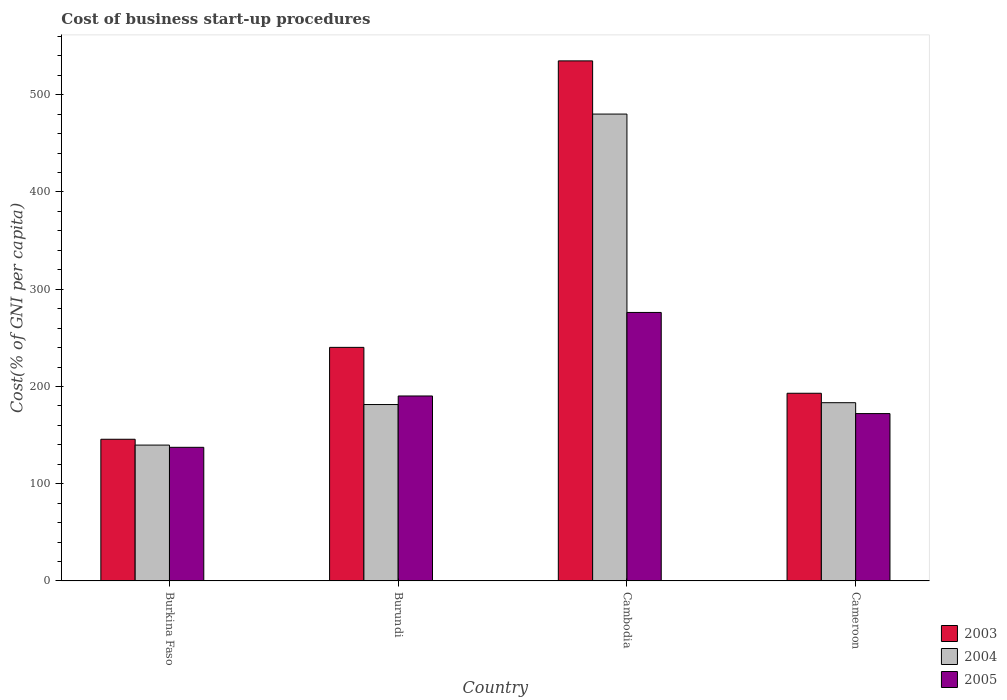How many different coloured bars are there?
Your response must be concise. 3. Are the number of bars per tick equal to the number of legend labels?
Give a very brief answer. Yes. How many bars are there on the 4th tick from the left?
Offer a terse response. 3. What is the label of the 4th group of bars from the left?
Give a very brief answer. Cameroon. What is the cost of business start-up procedures in 2003 in Cambodia?
Keep it short and to the point. 534.8. Across all countries, what is the maximum cost of business start-up procedures in 2003?
Ensure brevity in your answer.  534.8. Across all countries, what is the minimum cost of business start-up procedures in 2005?
Offer a very short reply. 137.4. In which country was the cost of business start-up procedures in 2005 maximum?
Ensure brevity in your answer.  Cambodia. In which country was the cost of business start-up procedures in 2005 minimum?
Make the answer very short. Burkina Faso. What is the total cost of business start-up procedures in 2004 in the graph?
Ensure brevity in your answer.  984.5. What is the difference between the cost of business start-up procedures in 2003 in Burundi and that in Cameroon?
Make the answer very short. 47.2. What is the difference between the cost of business start-up procedures in 2005 in Burundi and the cost of business start-up procedures in 2003 in Cambodia?
Offer a terse response. -344.6. What is the average cost of business start-up procedures in 2004 per country?
Make the answer very short. 246.12. What is the difference between the cost of business start-up procedures of/in 2005 and cost of business start-up procedures of/in 2004 in Burkina Faso?
Your response must be concise. -2.3. In how many countries, is the cost of business start-up procedures in 2003 greater than 500 %?
Offer a terse response. 1. What is the ratio of the cost of business start-up procedures in 2005 in Burkina Faso to that in Cambodia?
Offer a very short reply. 0.5. What is the difference between the highest and the second highest cost of business start-up procedures in 2003?
Offer a terse response. 47.2. What is the difference between the highest and the lowest cost of business start-up procedures in 2004?
Your answer should be very brief. 340.4. What does the 2nd bar from the left in Burundi represents?
Offer a very short reply. 2004. Is it the case that in every country, the sum of the cost of business start-up procedures in 2004 and cost of business start-up procedures in 2005 is greater than the cost of business start-up procedures in 2003?
Provide a succinct answer. Yes. How many bars are there?
Your answer should be compact. 12. Are all the bars in the graph horizontal?
Offer a terse response. No. How many countries are there in the graph?
Make the answer very short. 4. Are the values on the major ticks of Y-axis written in scientific E-notation?
Your answer should be very brief. No. How are the legend labels stacked?
Your response must be concise. Vertical. What is the title of the graph?
Keep it short and to the point. Cost of business start-up procedures. What is the label or title of the X-axis?
Offer a terse response. Country. What is the label or title of the Y-axis?
Make the answer very short. Cost(% of GNI per capita). What is the Cost(% of GNI per capita) of 2003 in Burkina Faso?
Give a very brief answer. 145.7. What is the Cost(% of GNI per capita) in 2004 in Burkina Faso?
Make the answer very short. 139.7. What is the Cost(% of GNI per capita) in 2005 in Burkina Faso?
Provide a succinct answer. 137.4. What is the Cost(% of GNI per capita) in 2003 in Burundi?
Your answer should be very brief. 240.2. What is the Cost(% of GNI per capita) of 2004 in Burundi?
Make the answer very short. 181.4. What is the Cost(% of GNI per capita) of 2005 in Burundi?
Provide a short and direct response. 190.2. What is the Cost(% of GNI per capita) of 2003 in Cambodia?
Offer a terse response. 534.8. What is the Cost(% of GNI per capita) in 2004 in Cambodia?
Your answer should be very brief. 480.1. What is the Cost(% of GNI per capita) in 2005 in Cambodia?
Offer a terse response. 276.1. What is the Cost(% of GNI per capita) of 2003 in Cameroon?
Your response must be concise. 193. What is the Cost(% of GNI per capita) of 2004 in Cameroon?
Ensure brevity in your answer.  183.3. What is the Cost(% of GNI per capita) in 2005 in Cameroon?
Give a very brief answer. 172.1. Across all countries, what is the maximum Cost(% of GNI per capita) of 2003?
Keep it short and to the point. 534.8. Across all countries, what is the maximum Cost(% of GNI per capita) in 2004?
Provide a short and direct response. 480.1. Across all countries, what is the maximum Cost(% of GNI per capita) of 2005?
Offer a very short reply. 276.1. Across all countries, what is the minimum Cost(% of GNI per capita) of 2003?
Provide a short and direct response. 145.7. Across all countries, what is the minimum Cost(% of GNI per capita) in 2004?
Your answer should be compact. 139.7. Across all countries, what is the minimum Cost(% of GNI per capita) of 2005?
Give a very brief answer. 137.4. What is the total Cost(% of GNI per capita) of 2003 in the graph?
Make the answer very short. 1113.7. What is the total Cost(% of GNI per capita) in 2004 in the graph?
Provide a succinct answer. 984.5. What is the total Cost(% of GNI per capita) in 2005 in the graph?
Make the answer very short. 775.8. What is the difference between the Cost(% of GNI per capita) in 2003 in Burkina Faso and that in Burundi?
Offer a very short reply. -94.5. What is the difference between the Cost(% of GNI per capita) of 2004 in Burkina Faso and that in Burundi?
Provide a short and direct response. -41.7. What is the difference between the Cost(% of GNI per capita) of 2005 in Burkina Faso and that in Burundi?
Ensure brevity in your answer.  -52.8. What is the difference between the Cost(% of GNI per capita) in 2003 in Burkina Faso and that in Cambodia?
Offer a very short reply. -389.1. What is the difference between the Cost(% of GNI per capita) in 2004 in Burkina Faso and that in Cambodia?
Your answer should be compact. -340.4. What is the difference between the Cost(% of GNI per capita) of 2005 in Burkina Faso and that in Cambodia?
Ensure brevity in your answer.  -138.7. What is the difference between the Cost(% of GNI per capita) in 2003 in Burkina Faso and that in Cameroon?
Give a very brief answer. -47.3. What is the difference between the Cost(% of GNI per capita) of 2004 in Burkina Faso and that in Cameroon?
Provide a short and direct response. -43.6. What is the difference between the Cost(% of GNI per capita) of 2005 in Burkina Faso and that in Cameroon?
Your response must be concise. -34.7. What is the difference between the Cost(% of GNI per capita) in 2003 in Burundi and that in Cambodia?
Make the answer very short. -294.6. What is the difference between the Cost(% of GNI per capita) of 2004 in Burundi and that in Cambodia?
Offer a terse response. -298.7. What is the difference between the Cost(% of GNI per capita) in 2005 in Burundi and that in Cambodia?
Provide a short and direct response. -85.9. What is the difference between the Cost(% of GNI per capita) of 2003 in Burundi and that in Cameroon?
Give a very brief answer. 47.2. What is the difference between the Cost(% of GNI per capita) of 2004 in Burundi and that in Cameroon?
Offer a very short reply. -1.9. What is the difference between the Cost(% of GNI per capita) of 2005 in Burundi and that in Cameroon?
Provide a succinct answer. 18.1. What is the difference between the Cost(% of GNI per capita) of 2003 in Cambodia and that in Cameroon?
Keep it short and to the point. 341.8. What is the difference between the Cost(% of GNI per capita) in 2004 in Cambodia and that in Cameroon?
Your answer should be compact. 296.8. What is the difference between the Cost(% of GNI per capita) of 2005 in Cambodia and that in Cameroon?
Make the answer very short. 104. What is the difference between the Cost(% of GNI per capita) of 2003 in Burkina Faso and the Cost(% of GNI per capita) of 2004 in Burundi?
Provide a short and direct response. -35.7. What is the difference between the Cost(% of GNI per capita) in 2003 in Burkina Faso and the Cost(% of GNI per capita) in 2005 in Burundi?
Offer a terse response. -44.5. What is the difference between the Cost(% of GNI per capita) of 2004 in Burkina Faso and the Cost(% of GNI per capita) of 2005 in Burundi?
Your answer should be very brief. -50.5. What is the difference between the Cost(% of GNI per capita) in 2003 in Burkina Faso and the Cost(% of GNI per capita) in 2004 in Cambodia?
Your response must be concise. -334.4. What is the difference between the Cost(% of GNI per capita) of 2003 in Burkina Faso and the Cost(% of GNI per capita) of 2005 in Cambodia?
Your answer should be compact. -130.4. What is the difference between the Cost(% of GNI per capita) in 2004 in Burkina Faso and the Cost(% of GNI per capita) in 2005 in Cambodia?
Keep it short and to the point. -136.4. What is the difference between the Cost(% of GNI per capita) of 2003 in Burkina Faso and the Cost(% of GNI per capita) of 2004 in Cameroon?
Offer a very short reply. -37.6. What is the difference between the Cost(% of GNI per capita) in 2003 in Burkina Faso and the Cost(% of GNI per capita) in 2005 in Cameroon?
Provide a short and direct response. -26.4. What is the difference between the Cost(% of GNI per capita) of 2004 in Burkina Faso and the Cost(% of GNI per capita) of 2005 in Cameroon?
Keep it short and to the point. -32.4. What is the difference between the Cost(% of GNI per capita) in 2003 in Burundi and the Cost(% of GNI per capita) in 2004 in Cambodia?
Make the answer very short. -239.9. What is the difference between the Cost(% of GNI per capita) in 2003 in Burundi and the Cost(% of GNI per capita) in 2005 in Cambodia?
Provide a short and direct response. -35.9. What is the difference between the Cost(% of GNI per capita) in 2004 in Burundi and the Cost(% of GNI per capita) in 2005 in Cambodia?
Offer a terse response. -94.7. What is the difference between the Cost(% of GNI per capita) in 2003 in Burundi and the Cost(% of GNI per capita) in 2004 in Cameroon?
Offer a terse response. 56.9. What is the difference between the Cost(% of GNI per capita) in 2003 in Burundi and the Cost(% of GNI per capita) in 2005 in Cameroon?
Provide a succinct answer. 68.1. What is the difference between the Cost(% of GNI per capita) of 2003 in Cambodia and the Cost(% of GNI per capita) of 2004 in Cameroon?
Make the answer very short. 351.5. What is the difference between the Cost(% of GNI per capita) of 2003 in Cambodia and the Cost(% of GNI per capita) of 2005 in Cameroon?
Make the answer very short. 362.7. What is the difference between the Cost(% of GNI per capita) in 2004 in Cambodia and the Cost(% of GNI per capita) in 2005 in Cameroon?
Give a very brief answer. 308. What is the average Cost(% of GNI per capita) of 2003 per country?
Give a very brief answer. 278.43. What is the average Cost(% of GNI per capita) of 2004 per country?
Give a very brief answer. 246.12. What is the average Cost(% of GNI per capita) of 2005 per country?
Offer a terse response. 193.95. What is the difference between the Cost(% of GNI per capita) of 2003 and Cost(% of GNI per capita) of 2005 in Burkina Faso?
Give a very brief answer. 8.3. What is the difference between the Cost(% of GNI per capita) of 2004 and Cost(% of GNI per capita) of 2005 in Burkina Faso?
Give a very brief answer. 2.3. What is the difference between the Cost(% of GNI per capita) in 2003 and Cost(% of GNI per capita) in 2004 in Burundi?
Keep it short and to the point. 58.8. What is the difference between the Cost(% of GNI per capita) of 2003 and Cost(% of GNI per capita) of 2005 in Burundi?
Keep it short and to the point. 50. What is the difference between the Cost(% of GNI per capita) of 2004 and Cost(% of GNI per capita) of 2005 in Burundi?
Your response must be concise. -8.8. What is the difference between the Cost(% of GNI per capita) of 2003 and Cost(% of GNI per capita) of 2004 in Cambodia?
Provide a succinct answer. 54.7. What is the difference between the Cost(% of GNI per capita) in 2003 and Cost(% of GNI per capita) in 2005 in Cambodia?
Provide a short and direct response. 258.7. What is the difference between the Cost(% of GNI per capita) of 2004 and Cost(% of GNI per capita) of 2005 in Cambodia?
Keep it short and to the point. 204. What is the difference between the Cost(% of GNI per capita) in 2003 and Cost(% of GNI per capita) in 2004 in Cameroon?
Offer a terse response. 9.7. What is the difference between the Cost(% of GNI per capita) in 2003 and Cost(% of GNI per capita) in 2005 in Cameroon?
Provide a short and direct response. 20.9. What is the difference between the Cost(% of GNI per capita) of 2004 and Cost(% of GNI per capita) of 2005 in Cameroon?
Offer a terse response. 11.2. What is the ratio of the Cost(% of GNI per capita) in 2003 in Burkina Faso to that in Burundi?
Make the answer very short. 0.61. What is the ratio of the Cost(% of GNI per capita) in 2004 in Burkina Faso to that in Burundi?
Offer a very short reply. 0.77. What is the ratio of the Cost(% of GNI per capita) of 2005 in Burkina Faso to that in Burundi?
Provide a succinct answer. 0.72. What is the ratio of the Cost(% of GNI per capita) of 2003 in Burkina Faso to that in Cambodia?
Keep it short and to the point. 0.27. What is the ratio of the Cost(% of GNI per capita) in 2004 in Burkina Faso to that in Cambodia?
Give a very brief answer. 0.29. What is the ratio of the Cost(% of GNI per capita) in 2005 in Burkina Faso to that in Cambodia?
Keep it short and to the point. 0.5. What is the ratio of the Cost(% of GNI per capita) in 2003 in Burkina Faso to that in Cameroon?
Provide a short and direct response. 0.75. What is the ratio of the Cost(% of GNI per capita) of 2004 in Burkina Faso to that in Cameroon?
Give a very brief answer. 0.76. What is the ratio of the Cost(% of GNI per capita) of 2005 in Burkina Faso to that in Cameroon?
Provide a short and direct response. 0.8. What is the ratio of the Cost(% of GNI per capita) in 2003 in Burundi to that in Cambodia?
Provide a short and direct response. 0.45. What is the ratio of the Cost(% of GNI per capita) in 2004 in Burundi to that in Cambodia?
Ensure brevity in your answer.  0.38. What is the ratio of the Cost(% of GNI per capita) in 2005 in Burundi to that in Cambodia?
Offer a terse response. 0.69. What is the ratio of the Cost(% of GNI per capita) in 2003 in Burundi to that in Cameroon?
Give a very brief answer. 1.24. What is the ratio of the Cost(% of GNI per capita) in 2005 in Burundi to that in Cameroon?
Your answer should be compact. 1.11. What is the ratio of the Cost(% of GNI per capita) in 2003 in Cambodia to that in Cameroon?
Your answer should be compact. 2.77. What is the ratio of the Cost(% of GNI per capita) of 2004 in Cambodia to that in Cameroon?
Give a very brief answer. 2.62. What is the ratio of the Cost(% of GNI per capita) of 2005 in Cambodia to that in Cameroon?
Offer a terse response. 1.6. What is the difference between the highest and the second highest Cost(% of GNI per capita) in 2003?
Make the answer very short. 294.6. What is the difference between the highest and the second highest Cost(% of GNI per capita) of 2004?
Provide a short and direct response. 296.8. What is the difference between the highest and the second highest Cost(% of GNI per capita) of 2005?
Ensure brevity in your answer.  85.9. What is the difference between the highest and the lowest Cost(% of GNI per capita) in 2003?
Your response must be concise. 389.1. What is the difference between the highest and the lowest Cost(% of GNI per capita) of 2004?
Make the answer very short. 340.4. What is the difference between the highest and the lowest Cost(% of GNI per capita) of 2005?
Offer a terse response. 138.7. 